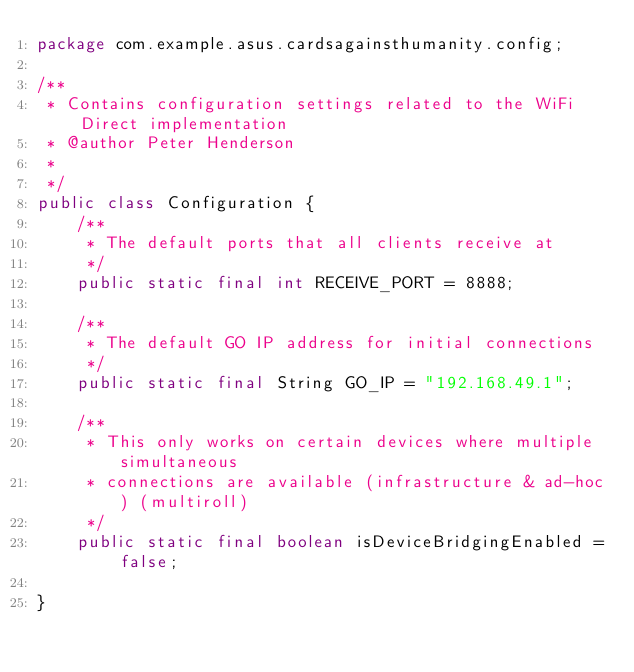Convert code to text. <code><loc_0><loc_0><loc_500><loc_500><_Java_>package com.example.asus.cardsagainsthumanity.config;

/**
 * Contains configuration settings related to the WiFi Direct implementation
 * @author Peter Henderson
 *
 */
public class Configuration {
    /**
     * The default ports that all clients receive at
     */
    public static final int RECEIVE_PORT = 8888;

    /**
     * The default GO IP address for initial connections
     */
    public static final String GO_IP = "192.168.49.1";

    /**
     * This only works on certain devices where multiple simultaneous
     * connections are available (infrastructure & ad-hoc) (multiroll)
     */
    public static final boolean isDeviceBridgingEnabled = false;

}</code> 